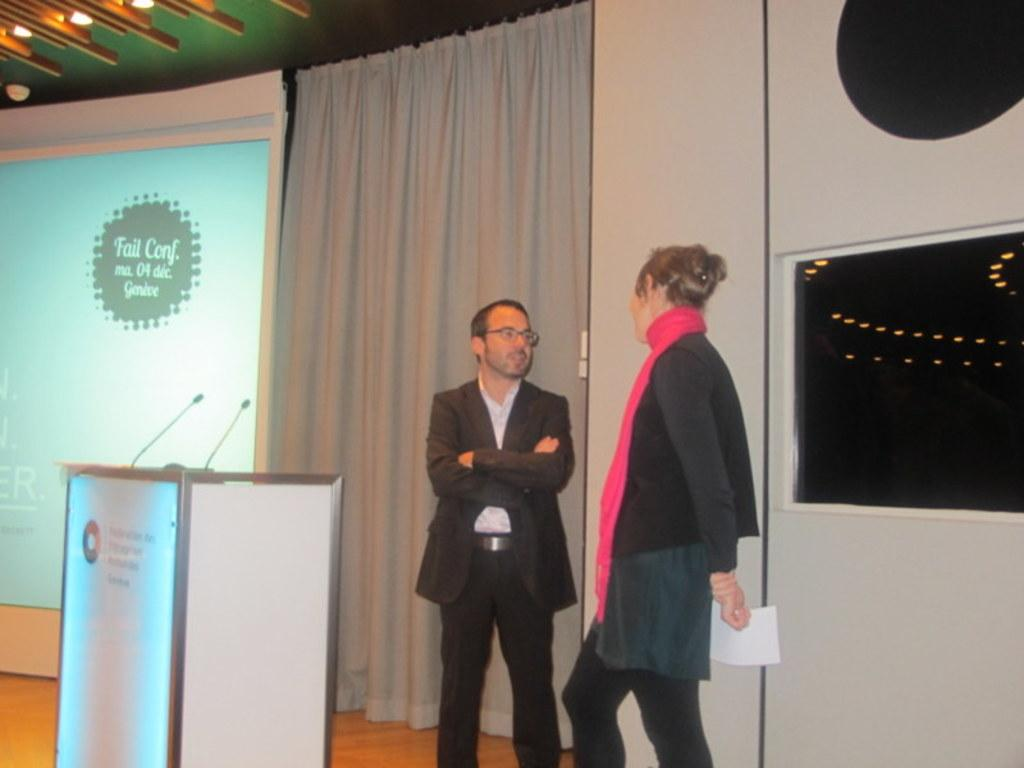<image>
Write a terse but informative summary of the picture. A man an woman chat near the podium of the Fail Conference. 